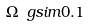<formula> <loc_0><loc_0><loc_500><loc_500>\Omega \ g s i m 0 . 1</formula> 